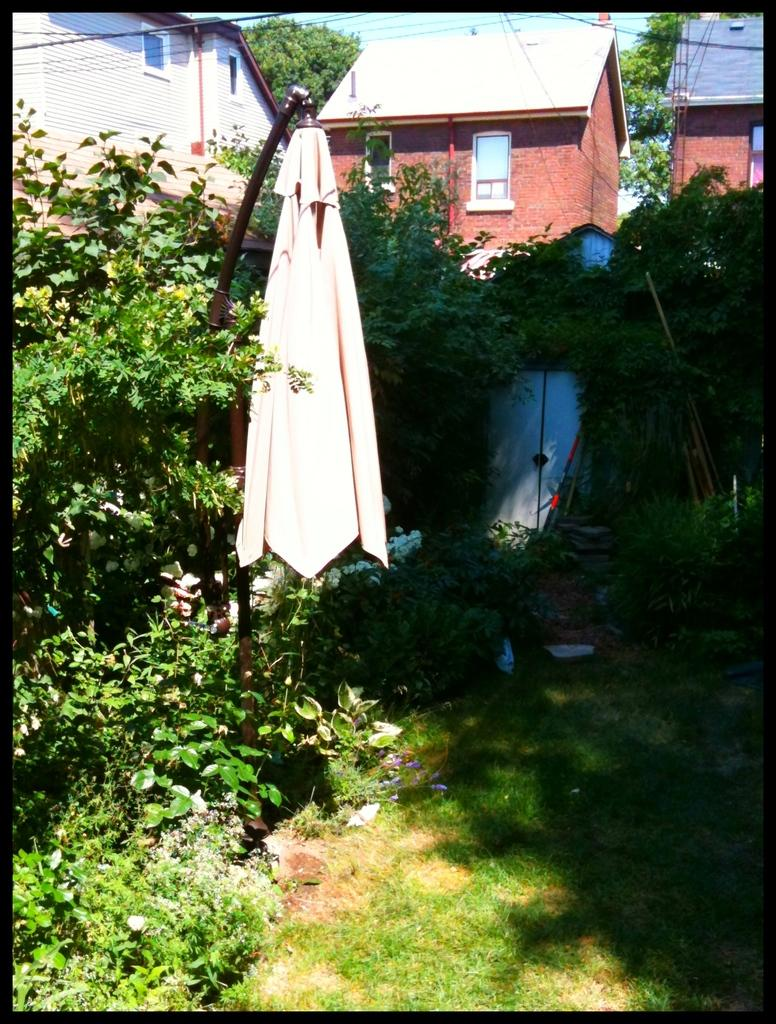Where was the image taken? The image was taken in the backyard of a house. What can be seen in the foreground of the image? There are plants and grass in the foreground of the image, as well as a shirt. What is visible in the background of the image? There are houses and trees in the background of the image. What is the weather like in the image? It is sunny in the image. Can you see a stranger holding a balloon in the image? There is no stranger holding a balloon in the image. Is there a quiver visible in the image? There is no quiver present in the image. 